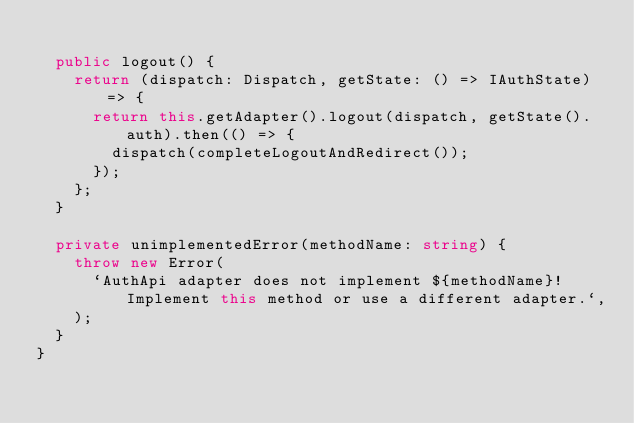<code> <loc_0><loc_0><loc_500><loc_500><_TypeScript_>
  public logout() {
    return (dispatch: Dispatch, getState: () => IAuthState) => {
      return this.getAdapter().logout(dispatch, getState().auth).then(() => {
        dispatch(completeLogoutAndRedirect());
      });
    };
  }

  private unimplementedError(methodName: string) {
    throw new Error(
      `AuthApi adapter does not implement ${methodName}! Implement this method or use a different adapter.`,
    );
  }
}
</code> 